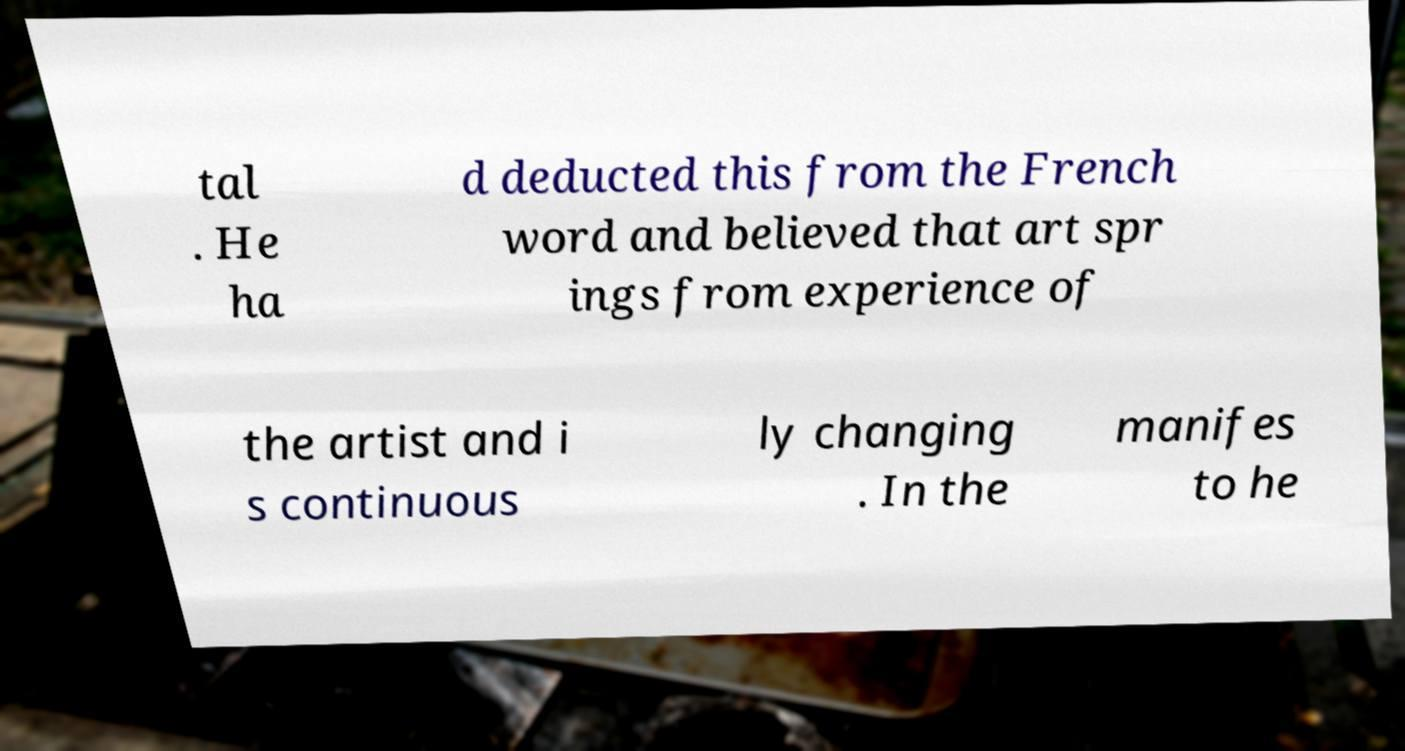Can you read and provide the text displayed in the image?This photo seems to have some interesting text. Can you extract and type it out for me? tal . He ha d deducted this from the French word and believed that art spr ings from experience of the artist and i s continuous ly changing . In the manifes to he 